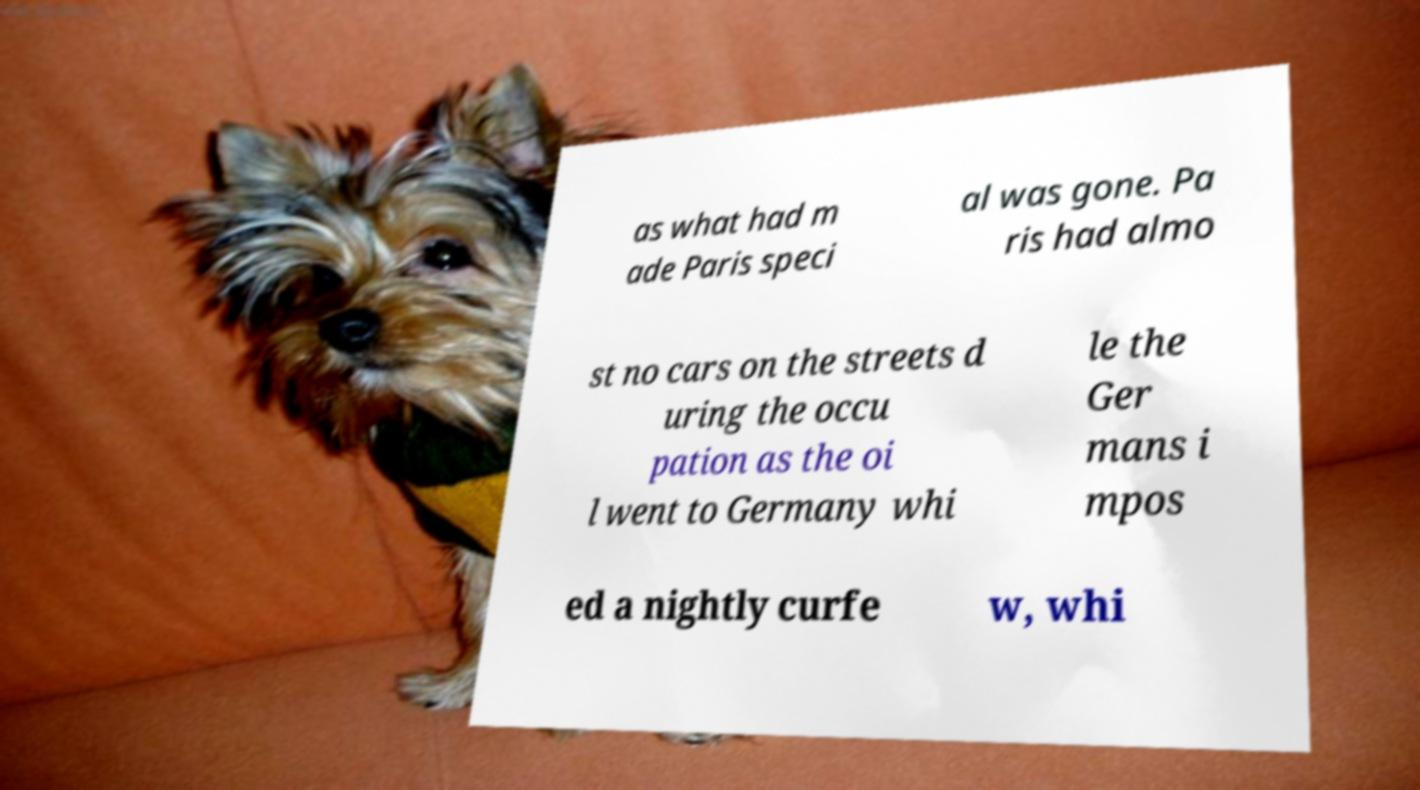For documentation purposes, I need the text within this image transcribed. Could you provide that? as what had m ade Paris speci al was gone. Pa ris had almo st no cars on the streets d uring the occu pation as the oi l went to Germany whi le the Ger mans i mpos ed a nightly curfe w, whi 